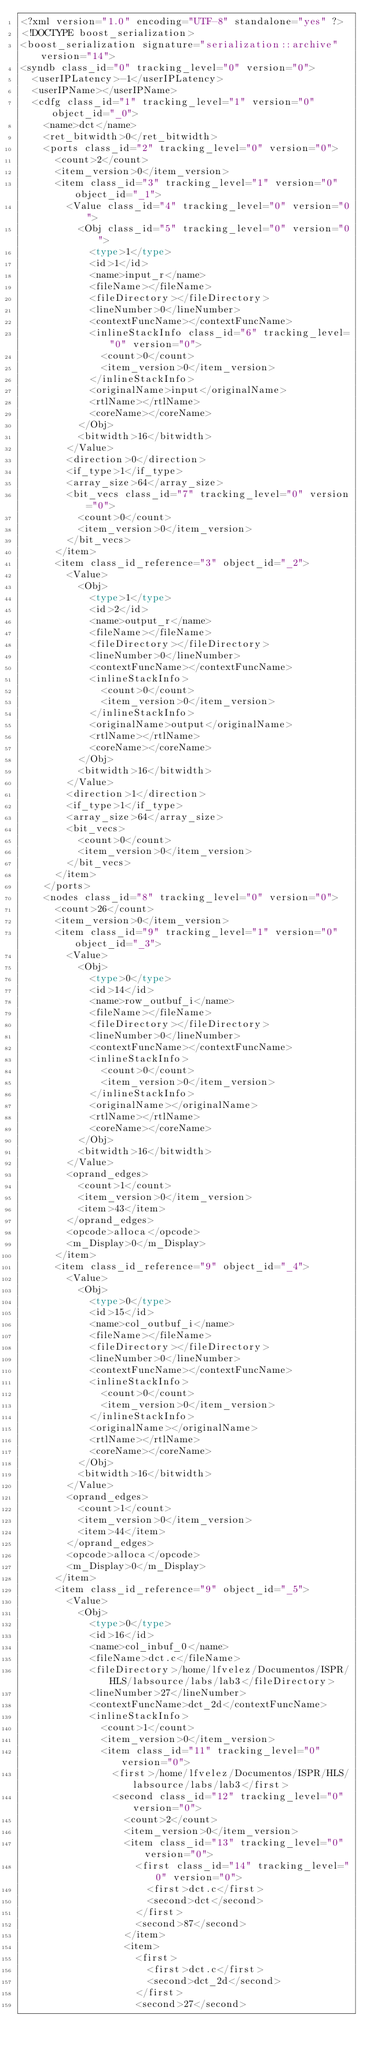Convert code to text. <code><loc_0><loc_0><loc_500><loc_500><_Ada_><?xml version="1.0" encoding="UTF-8" standalone="yes" ?>
<!DOCTYPE boost_serialization>
<boost_serialization signature="serialization::archive" version="14">
<syndb class_id="0" tracking_level="0" version="0">
	<userIPLatency>-1</userIPLatency>
	<userIPName></userIPName>
	<cdfg class_id="1" tracking_level="1" version="0" object_id="_0">
		<name>dct</name>
		<ret_bitwidth>0</ret_bitwidth>
		<ports class_id="2" tracking_level="0" version="0">
			<count>2</count>
			<item_version>0</item_version>
			<item class_id="3" tracking_level="1" version="0" object_id="_1">
				<Value class_id="4" tracking_level="0" version="0">
					<Obj class_id="5" tracking_level="0" version="0">
						<type>1</type>
						<id>1</id>
						<name>input_r</name>
						<fileName></fileName>
						<fileDirectory></fileDirectory>
						<lineNumber>0</lineNumber>
						<contextFuncName></contextFuncName>
						<inlineStackInfo class_id="6" tracking_level="0" version="0">
							<count>0</count>
							<item_version>0</item_version>
						</inlineStackInfo>
						<originalName>input</originalName>
						<rtlName></rtlName>
						<coreName></coreName>
					</Obj>
					<bitwidth>16</bitwidth>
				</Value>
				<direction>0</direction>
				<if_type>1</if_type>
				<array_size>64</array_size>
				<bit_vecs class_id="7" tracking_level="0" version="0">
					<count>0</count>
					<item_version>0</item_version>
				</bit_vecs>
			</item>
			<item class_id_reference="3" object_id="_2">
				<Value>
					<Obj>
						<type>1</type>
						<id>2</id>
						<name>output_r</name>
						<fileName></fileName>
						<fileDirectory></fileDirectory>
						<lineNumber>0</lineNumber>
						<contextFuncName></contextFuncName>
						<inlineStackInfo>
							<count>0</count>
							<item_version>0</item_version>
						</inlineStackInfo>
						<originalName>output</originalName>
						<rtlName></rtlName>
						<coreName></coreName>
					</Obj>
					<bitwidth>16</bitwidth>
				</Value>
				<direction>1</direction>
				<if_type>1</if_type>
				<array_size>64</array_size>
				<bit_vecs>
					<count>0</count>
					<item_version>0</item_version>
				</bit_vecs>
			</item>
		</ports>
		<nodes class_id="8" tracking_level="0" version="0">
			<count>26</count>
			<item_version>0</item_version>
			<item class_id="9" tracking_level="1" version="0" object_id="_3">
				<Value>
					<Obj>
						<type>0</type>
						<id>14</id>
						<name>row_outbuf_i</name>
						<fileName></fileName>
						<fileDirectory></fileDirectory>
						<lineNumber>0</lineNumber>
						<contextFuncName></contextFuncName>
						<inlineStackInfo>
							<count>0</count>
							<item_version>0</item_version>
						</inlineStackInfo>
						<originalName></originalName>
						<rtlName></rtlName>
						<coreName></coreName>
					</Obj>
					<bitwidth>16</bitwidth>
				</Value>
				<oprand_edges>
					<count>1</count>
					<item_version>0</item_version>
					<item>43</item>
				</oprand_edges>
				<opcode>alloca</opcode>
				<m_Display>0</m_Display>
			</item>
			<item class_id_reference="9" object_id="_4">
				<Value>
					<Obj>
						<type>0</type>
						<id>15</id>
						<name>col_outbuf_i</name>
						<fileName></fileName>
						<fileDirectory></fileDirectory>
						<lineNumber>0</lineNumber>
						<contextFuncName></contextFuncName>
						<inlineStackInfo>
							<count>0</count>
							<item_version>0</item_version>
						</inlineStackInfo>
						<originalName></originalName>
						<rtlName></rtlName>
						<coreName></coreName>
					</Obj>
					<bitwidth>16</bitwidth>
				</Value>
				<oprand_edges>
					<count>1</count>
					<item_version>0</item_version>
					<item>44</item>
				</oprand_edges>
				<opcode>alloca</opcode>
				<m_Display>0</m_Display>
			</item>
			<item class_id_reference="9" object_id="_5">
				<Value>
					<Obj>
						<type>0</type>
						<id>16</id>
						<name>col_inbuf_0</name>
						<fileName>dct.c</fileName>
						<fileDirectory>/home/lfvelez/Documentos/ISPR/HLS/labsource/labs/lab3</fileDirectory>
						<lineNumber>27</lineNumber>
						<contextFuncName>dct_2d</contextFuncName>
						<inlineStackInfo>
							<count>1</count>
							<item_version>0</item_version>
							<item class_id="11" tracking_level="0" version="0">
								<first>/home/lfvelez/Documentos/ISPR/HLS/labsource/labs/lab3</first>
								<second class_id="12" tracking_level="0" version="0">
									<count>2</count>
									<item_version>0</item_version>
									<item class_id="13" tracking_level="0" version="0">
										<first class_id="14" tracking_level="0" version="0">
											<first>dct.c</first>
											<second>dct</second>
										</first>
										<second>87</second>
									</item>
									<item>
										<first>
											<first>dct.c</first>
											<second>dct_2d</second>
										</first>
										<second>27</second></code> 